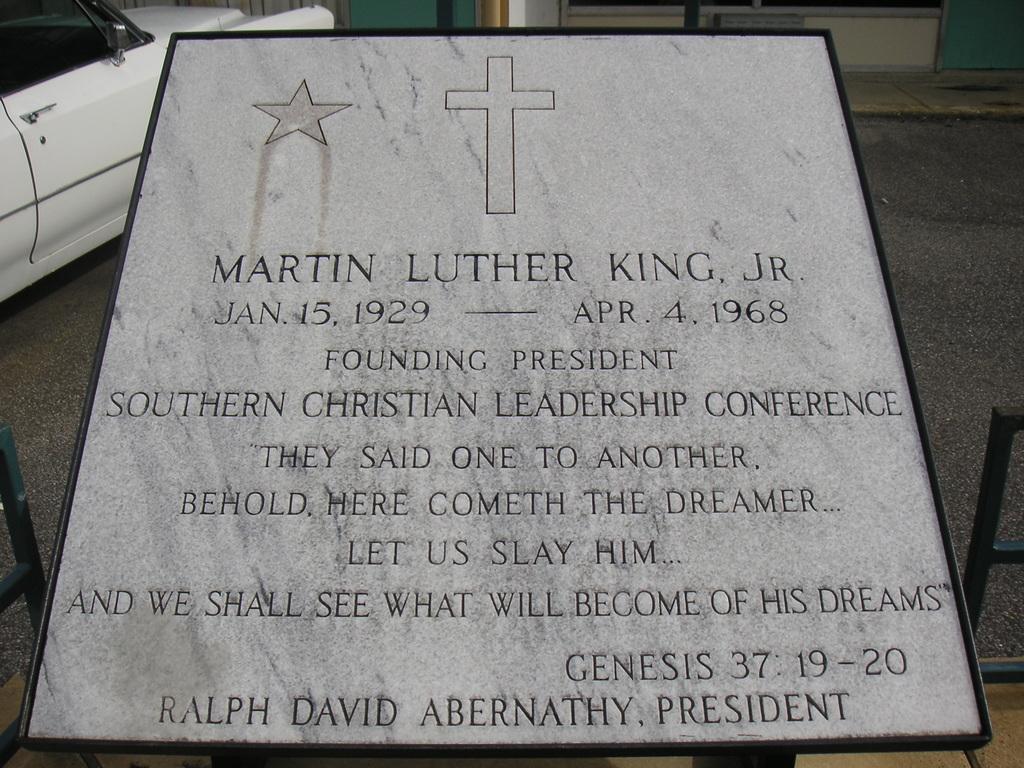In one or two sentences, can you explain what this image depicts? Here we can see board with information and we can see car. 